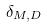<formula> <loc_0><loc_0><loc_500><loc_500>\delta _ { M , D }</formula> 